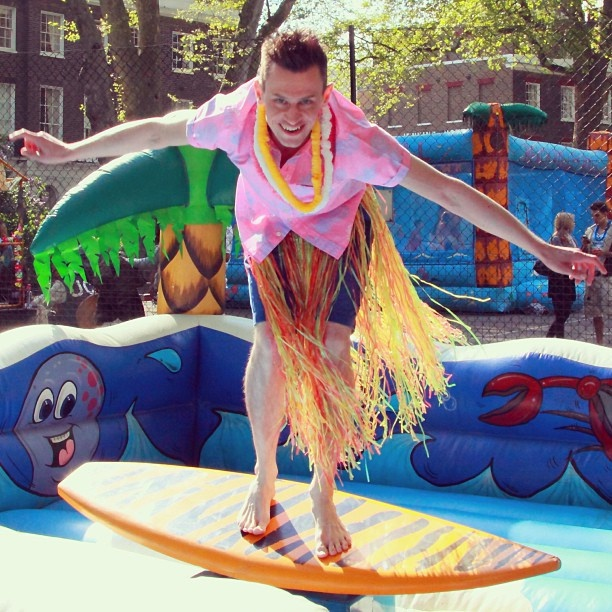Describe the objects in this image and their specific colors. I can see people in purple, brown, darkgray, violet, and lightpink tones, surfboard in purple, beige, khaki, red, and orange tones, people in purple, black, and gray tones, people in purple, gray, maroon, and black tones, and people in purple, black, gray, and darkgray tones in this image. 